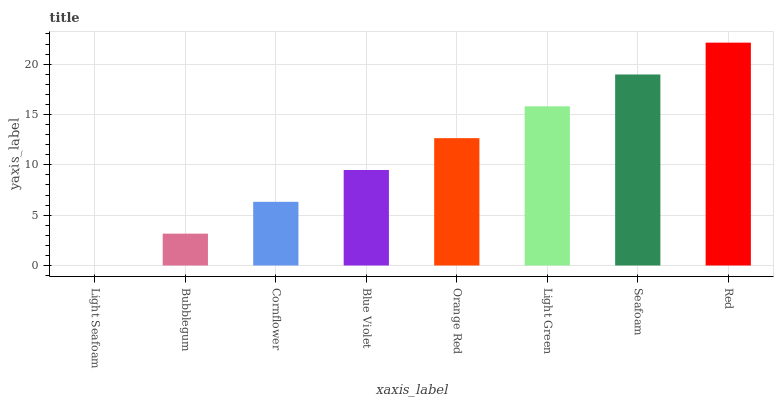Is Light Seafoam the minimum?
Answer yes or no. Yes. Is Red the maximum?
Answer yes or no. Yes. Is Bubblegum the minimum?
Answer yes or no. No. Is Bubblegum the maximum?
Answer yes or no. No. Is Bubblegum greater than Light Seafoam?
Answer yes or no. Yes. Is Light Seafoam less than Bubblegum?
Answer yes or no. Yes. Is Light Seafoam greater than Bubblegum?
Answer yes or no. No. Is Bubblegum less than Light Seafoam?
Answer yes or no. No. Is Orange Red the high median?
Answer yes or no. Yes. Is Blue Violet the low median?
Answer yes or no. Yes. Is Seafoam the high median?
Answer yes or no. No. Is Bubblegum the low median?
Answer yes or no. No. 